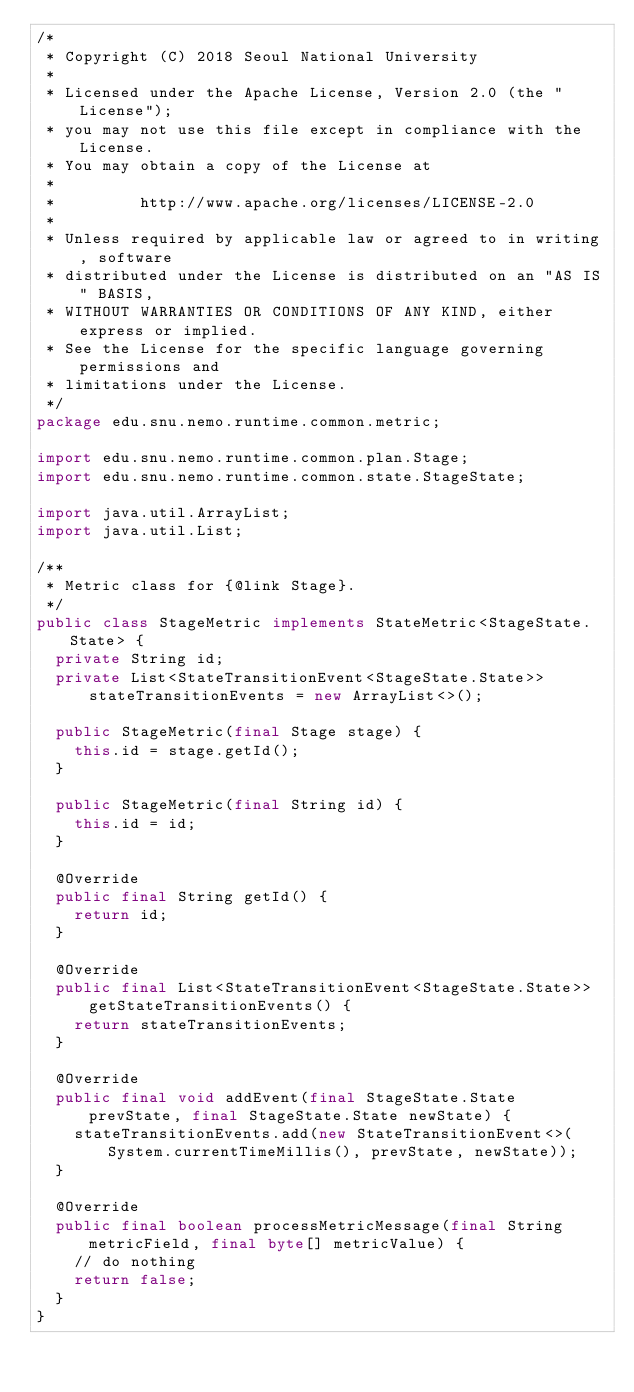Convert code to text. <code><loc_0><loc_0><loc_500><loc_500><_Java_>/*
 * Copyright (C) 2018 Seoul National University
 *
 * Licensed under the Apache License, Version 2.0 (the "License");
 * you may not use this file except in compliance with the License.
 * You may obtain a copy of the License at
 *
 *         http://www.apache.org/licenses/LICENSE-2.0
 *
 * Unless required by applicable law or agreed to in writing, software
 * distributed under the License is distributed on an "AS IS" BASIS,
 * WITHOUT WARRANTIES OR CONDITIONS OF ANY KIND, either express or implied.
 * See the License for the specific language governing permissions and
 * limitations under the License.
 */
package edu.snu.nemo.runtime.common.metric;

import edu.snu.nemo.runtime.common.plan.Stage;
import edu.snu.nemo.runtime.common.state.StageState;

import java.util.ArrayList;
import java.util.List;

/**
 * Metric class for {@link Stage}.
 */
public class StageMetric implements StateMetric<StageState.State> {
  private String id;
  private List<StateTransitionEvent<StageState.State>> stateTransitionEvents = new ArrayList<>();

  public StageMetric(final Stage stage) {
    this.id = stage.getId();
  }

  public StageMetric(final String id) {
    this.id = id;
  }

  @Override
  public final String getId() {
    return id;
  }

  @Override
  public final List<StateTransitionEvent<StageState.State>> getStateTransitionEvents() {
    return stateTransitionEvents;
  }

  @Override
  public final void addEvent(final StageState.State prevState, final StageState.State newState) {
    stateTransitionEvents.add(new StateTransitionEvent<>(System.currentTimeMillis(), prevState, newState));
  }

  @Override
  public final boolean processMetricMessage(final String metricField, final byte[] metricValue) {
    // do nothing
    return false;
  }
}
</code> 